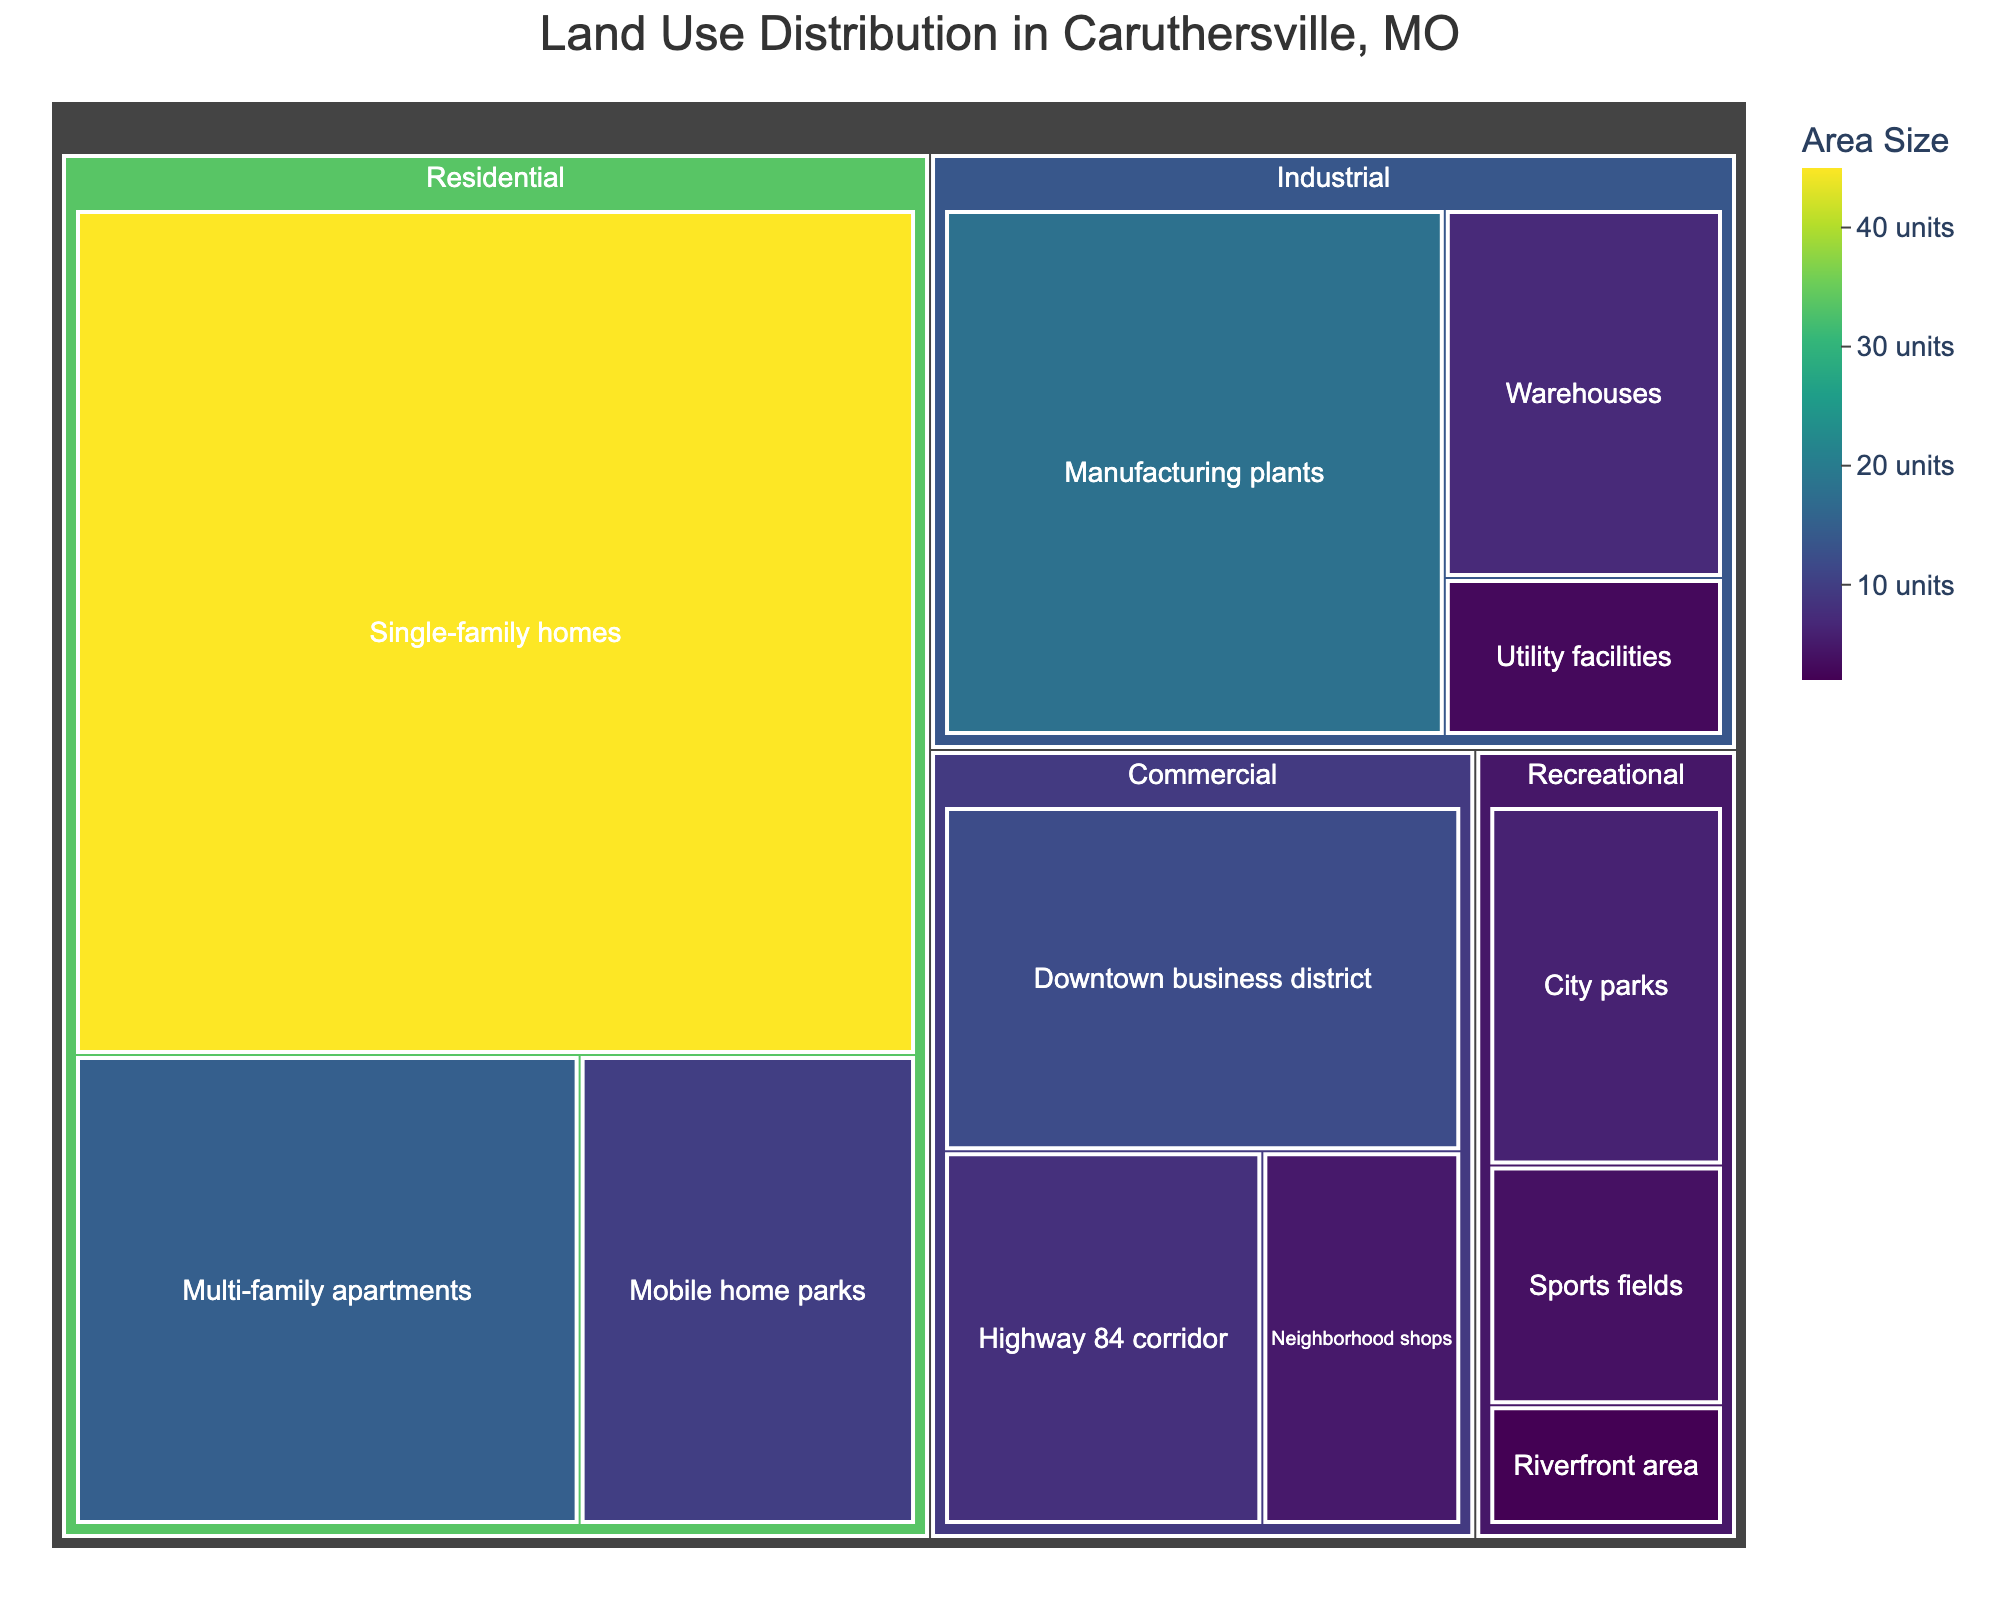What's the largest category in terms of land use area? By looking at the treemap, the size of the sections represents the area. The largest section belongs to the "Residential" category.
Answer: Residential What is the total area for industrial land use? By summing the values for the subcategories under "Industrial" (Manufacturing plants: 18, Warehouses: 7, Utility facilities: 3), the total area is 18 + 7 + 3 = 28 units.
Answer: 28 units Which subcategory has the smallest land use area? Examine the smaller squares in the treemap. The "Riverfront area" under "Recreational" has the smallest value of 2 units.
Answer: Riverfront area How much more land is used for single-family homes compared to downtown business districts? The value for single-family homes is 45 units, and for downtown business districts, it is 12 units. The difference is 45 - 12 = 33 units.
Answer: 33 units What is the combined area of city parks and sports fields? The value for city parks is 6 units and for sports fields, it is 4 units. The combined area is 6 + 4 = 10 units.
Answer: 10 units Which has more land area: multi-family apartments or the Highway 84 corridor? The value for multi-family apartments is 15 units, and for the Highway 84 corridor, it is 8 units. Multi-family apartments have more land area.
Answer: Multi-family apartments What category uses the second most land area after residential? By comparing the areas of other categories, the "Industrial" category follows "Residential" in terms of land area.
Answer: Industrial What percentage of land use is dedicated to mobile home parks within the residential category? The total area for the residential category is 45 + 15 + 10 = 70 units. The area for mobile home parks is 10 units. The percentage is (10 / 70) * 100 ≈ 14.28%.
Answer: 14.28% How do the areas for recreational land use compare across subcategories? The areas are 6 units for city parks, 4 units for sports fields, and 2 units for the riverfront area. This shows decreasing land use from city parks to the riverfront area.
Answer: City parks > Sports fields > Riverfront area If we were to reassign 5 units of land from utility facilities to city parks, how would the new areas compare? Initial areas are utility facilities: 3 units, city parks: 6 units. After reassigning 5 units, utility facilities become 3 - 5 = -2 units, and city parks become 6 + 5 = 11 units. However, land can't be negative, resulting in utility facilities reducing to 0 and city parks increasing to 9 units.
Answer: Utility facilities: 0 units, City parks: 9 units 